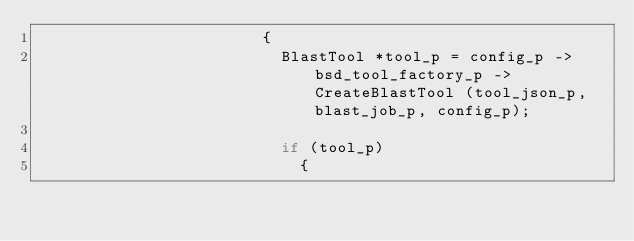Convert code to text. <code><loc_0><loc_0><loc_500><loc_500><_C_>												{
													BlastTool *tool_p = config_p -> bsd_tool_factory_p -> CreateBlastTool (tool_json_p, blast_job_p, config_p);

													if (tool_p)
														{</code> 